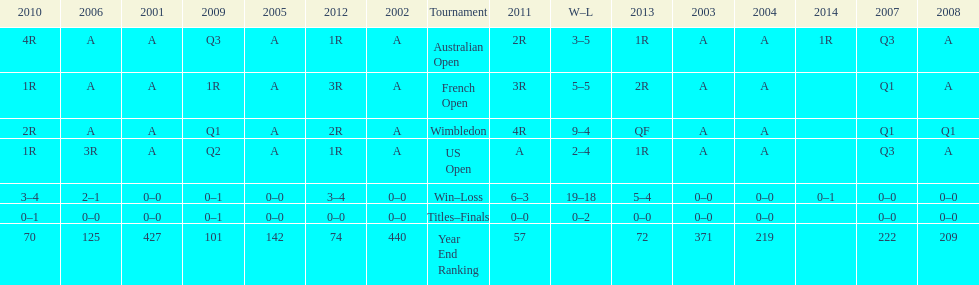What was this players ranking after 2005? 125. Would you be able to parse every entry in this table? {'header': ['2010', '2006', '2001', '2009', '2005', '2012', '2002', 'Tournament', '2011', 'W–L', '2013', '2003', '2004', '2014', '2007', '2008'], 'rows': [['4R', 'A', 'A', 'Q3', 'A', '1R', 'A', 'Australian Open', '2R', '3–5', '1R', 'A', 'A', '1R', 'Q3', 'A'], ['1R', 'A', 'A', '1R', 'A', '3R', 'A', 'French Open', '3R', '5–5', '2R', 'A', 'A', '', 'Q1', 'A'], ['2R', 'A', 'A', 'Q1', 'A', '2R', 'A', 'Wimbledon', '4R', '9–4', 'QF', 'A', 'A', '', 'Q1', 'Q1'], ['1R', '3R', 'A', 'Q2', 'A', '1R', 'A', 'US Open', 'A', '2–4', '1R', 'A', 'A', '', 'Q3', 'A'], ['3–4', '2–1', '0–0', '0–1', '0–0', '3–4', '0–0', 'Win–Loss', '6–3', '19–18', '5–4', '0–0', '0–0', '0–1', '0–0', '0–0'], ['0–1', '0–0', '0–0', '0–1', '0–0', '0–0', '0–0', 'Titles–Finals', '0–0', '0–2', '0–0', '0–0', '0–0', '', '0–0', '0–0'], ['70', '125', '427', '101', '142', '74', '440', 'Year End Ranking', '57', '', '72', '371', '219', '', '222', '209']]} 